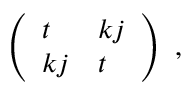Convert formula to latex. <formula><loc_0><loc_0><loc_500><loc_500>\begin{array} { r } { \left ( \begin{array} { l l } { t } & { k j } \\ { k j } & { t } \end{array} \right ) } \end{array} ,</formula> 